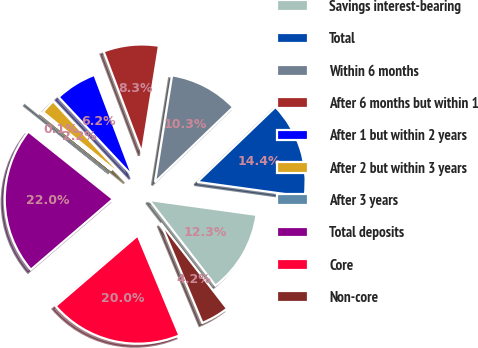Convert chart to OTSL. <chart><loc_0><loc_0><loc_500><loc_500><pie_chart><fcel>Savings interest-bearing<fcel>Total<fcel>Within 6 months<fcel>After 6 months but within 1<fcel>After 1 but within 2 years<fcel>After 2 but within 3 years<fcel>After 3 years<fcel>Total deposits<fcel>Core<fcel>Non-core<nl><fcel>12.33%<fcel>14.36%<fcel>10.3%<fcel>8.27%<fcel>6.23%<fcel>2.17%<fcel>0.14%<fcel>22.02%<fcel>19.98%<fcel>4.2%<nl></chart> 